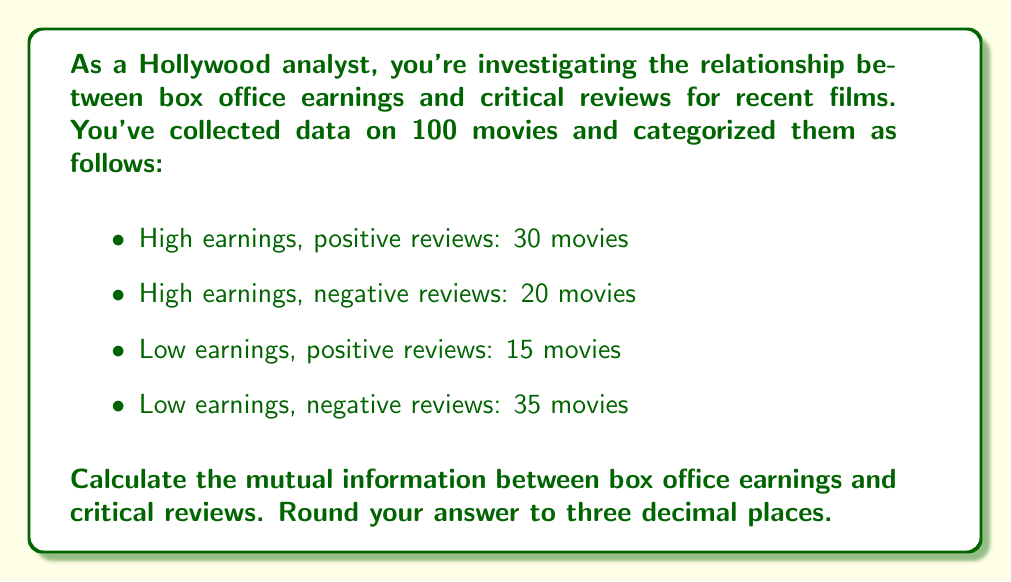Teach me how to tackle this problem. To calculate the mutual information between box office earnings and critical reviews, we'll follow these steps:

1) First, let's define our variables:
   X: Box office earnings (High or Low)
   Y: Critical reviews (Positive or Negative)

2) Calculate the marginal probabilities:
   P(X = High) = (30 + 20) / 100 = 0.5
   P(X = Low) = (15 + 35) / 100 = 0.5
   P(Y = Positive) = (30 + 15) / 100 = 0.45
   P(Y = Negative) = (20 + 35) / 100 = 0.55

3) Calculate the joint probabilities:
   P(X = High, Y = Positive) = 30 / 100 = 0.3
   P(X = High, Y = Negative) = 20 / 100 = 0.2
   P(X = Low, Y = Positive) = 15 / 100 = 0.15
   P(X = Low, Y = Negative) = 35 / 100 = 0.35

4) The mutual information I(X;Y) is given by:

   $$I(X;Y) = \sum_{x \in X} \sum_{y \in Y} P(x,y) \log_2 \frac{P(x,y)}{P(x)P(y)}$$

5) Let's calculate each term:
   
   $$0.3 \log_2 \frac{0.3}{0.5 \cdot 0.45} + 0.2 \log_2 \frac{0.2}{0.5 \cdot 0.55} + 0.15 \log_2 \frac{0.15}{0.5 \cdot 0.45} + 0.35 \log_2 \frac{0.35}{0.5 \cdot 0.55}$$

6) Calculating:
   
   $$0.3 \log_2 1.3333 + 0.2 \log_2 0.7273 + 0.15 \log_2 0.6667 + 0.35 \log_2 1.2727$$
   
   $$= 0.3 \cdot 0.4150 + 0.2 \cdot (-0.4594) + 0.15 \cdot (-0.5850) + 0.35 \cdot 0.3479$$
   
   $$= 0.1245 - 0.0919 - 0.0878 + 0.1218$$
   
   $$= 0.0666$$

7) Rounding to three decimal places:

   $$I(X;Y) \approx 0.067 \text{ bits}$$
Answer: 0.067 bits 